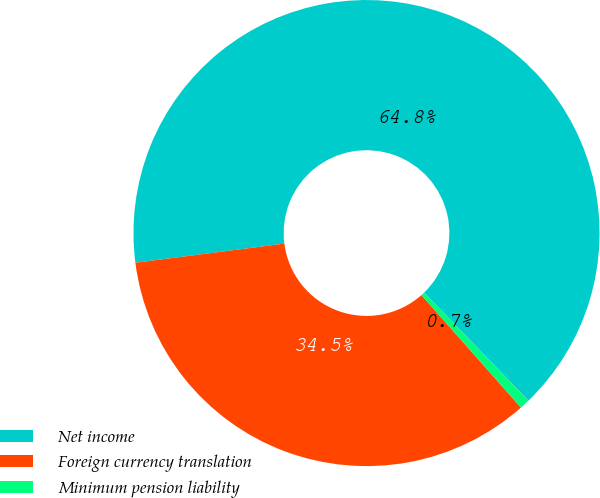Convert chart to OTSL. <chart><loc_0><loc_0><loc_500><loc_500><pie_chart><fcel>Net income<fcel>Foreign currency translation<fcel>Minimum pension liability<nl><fcel>64.81%<fcel>34.5%<fcel>0.69%<nl></chart> 